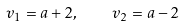Convert formula to latex. <formula><loc_0><loc_0><loc_500><loc_500>v _ { 1 } = a + 2 , \quad v _ { 2 } = a - 2</formula> 